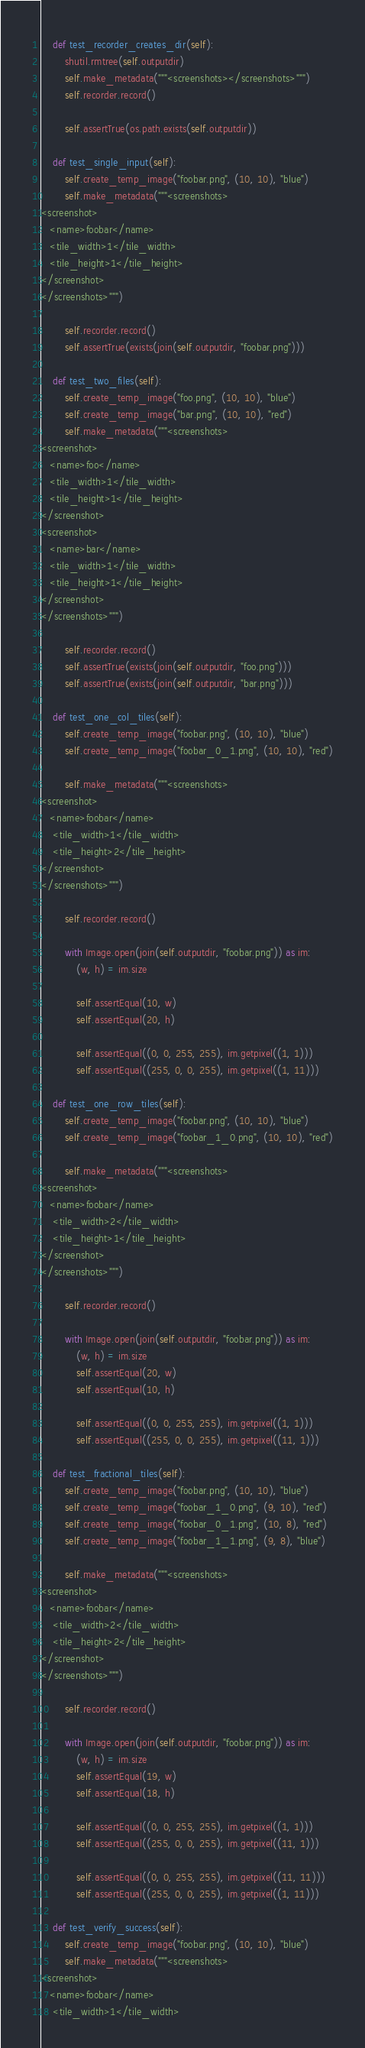Convert code to text. <code><loc_0><loc_0><loc_500><loc_500><_Python_>
    def test_recorder_creates_dir(self):
        shutil.rmtree(self.outputdir)
        self.make_metadata("""<screenshots></screenshots>""")
        self.recorder.record()

        self.assertTrue(os.path.exists(self.outputdir))

    def test_single_input(self):
        self.create_temp_image("foobar.png", (10, 10), "blue")
        self.make_metadata("""<screenshots>
<screenshot>
   <name>foobar</name>
   <tile_width>1</tile_width>
   <tile_height>1</tile_height>
</screenshot>
</screenshots>""")

        self.recorder.record()
        self.assertTrue(exists(join(self.outputdir, "foobar.png")))

    def test_two_files(self):
        self.create_temp_image("foo.png", (10, 10), "blue")
        self.create_temp_image("bar.png", (10, 10), "red")
        self.make_metadata("""<screenshots>
<screenshot>
   <name>foo</name>
   <tile_width>1</tile_width>
   <tile_height>1</tile_height>
</screenshot>
<screenshot>
   <name>bar</name>
   <tile_width>1</tile_width>
   <tile_height>1</tile_height>
</screenshot>
</screenshots>""")

        self.recorder.record()
        self.assertTrue(exists(join(self.outputdir, "foo.png")))
        self.assertTrue(exists(join(self.outputdir, "bar.png")))

    def test_one_col_tiles(self):
        self.create_temp_image("foobar.png", (10, 10), "blue")
        self.create_temp_image("foobar_0_1.png", (10, 10), "red")

        self.make_metadata("""<screenshots>
<screenshot>
   <name>foobar</name>
    <tile_width>1</tile_width>
    <tile_height>2</tile_height>
</screenshot>
</screenshots>""")

        self.recorder.record()

        with Image.open(join(self.outputdir, "foobar.png")) as im:
            (w, h) = im.size

            self.assertEqual(10, w)
            self.assertEqual(20, h)

            self.assertEqual((0, 0, 255, 255), im.getpixel((1, 1)))
            self.assertEqual((255, 0, 0, 255), im.getpixel((1, 11)))

    def test_one_row_tiles(self):
        self.create_temp_image("foobar.png", (10, 10), "blue")
        self.create_temp_image("foobar_1_0.png", (10, 10), "red")

        self.make_metadata("""<screenshots>
<screenshot>
   <name>foobar</name>
    <tile_width>2</tile_width>
    <tile_height>1</tile_height>
</screenshot>
</screenshots>""")

        self.recorder.record()

        with Image.open(join(self.outputdir, "foobar.png")) as im:
            (w, h) = im.size
            self.assertEqual(20, w)
            self.assertEqual(10, h)

            self.assertEqual((0, 0, 255, 255), im.getpixel((1, 1)))
            self.assertEqual((255, 0, 0, 255), im.getpixel((11, 1)))

    def test_fractional_tiles(self):
        self.create_temp_image("foobar.png", (10, 10), "blue")
        self.create_temp_image("foobar_1_0.png", (9, 10), "red")
        self.create_temp_image("foobar_0_1.png", (10, 8), "red")
        self.create_temp_image("foobar_1_1.png", (9, 8), "blue")

        self.make_metadata("""<screenshots>
<screenshot>
   <name>foobar</name>
    <tile_width>2</tile_width>
    <tile_height>2</tile_height>
</screenshot>
</screenshots>""")

        self.recorder.record()

        with Image.open(join(self.outputdir, "foobar.png")) as im:
            (w, h) = im.size
            self.assertEqual(19, w)
            self.assertEqual(18, h)

            self.assertEqual((0, 0, 255, 255), im.getpixel((1, 1)))
            self.assertEqual((255, 0, 0, 255), im.getpixel((11, 1)))

            self.assertEqual((0, 0, 255, 255), im.getpixel((11, 11)))
            self.assertEqual((255, 0, 0, 255), im.getpixel((1, 11)))

    def test_verify_success(self):
        self.create_temp_image("foobar.png", (10, 10), "blue")
        self.make_metadata("""<screenshots>
<screenshot>
   <name>foobar</name>
    <tile_width>1</tile_width></code> 